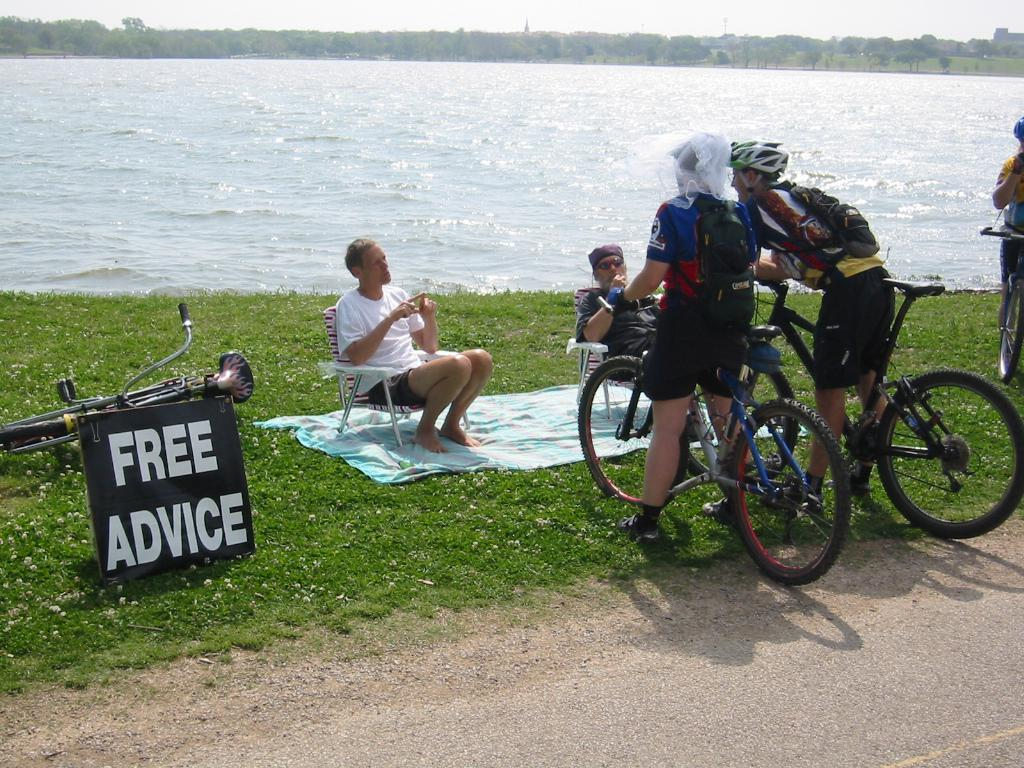What are the two persons holding in the image? The two persons are holding a bicycle. How many people are on the bicycle in the image? There are three other persons aboard the bicycle, making a total of five people. What can be seen in the background of the image? There is a body of water, a tree, and the sky visible in the image. What color is the mass of the cook in the image? There is no cook present in the image, and therefore no mass to describe. 